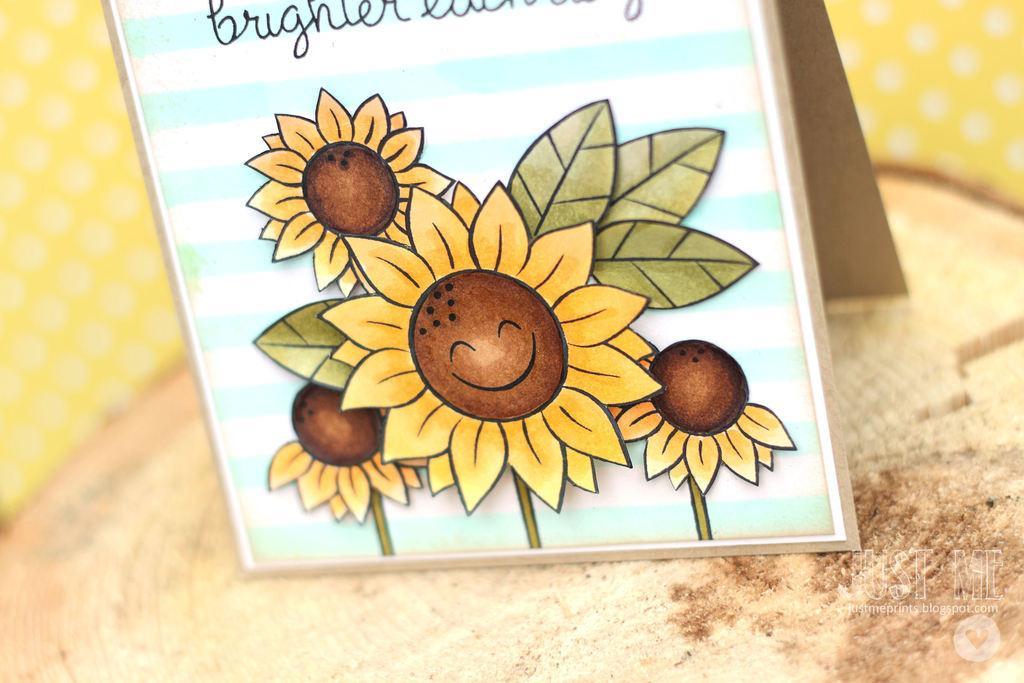Please provide a concise description of this image. In this image I can see a cardboard sheet, on the sheet I can see few flowers in yellow and brown color, and I can see something written on the board and I can see yellow and white color background. 